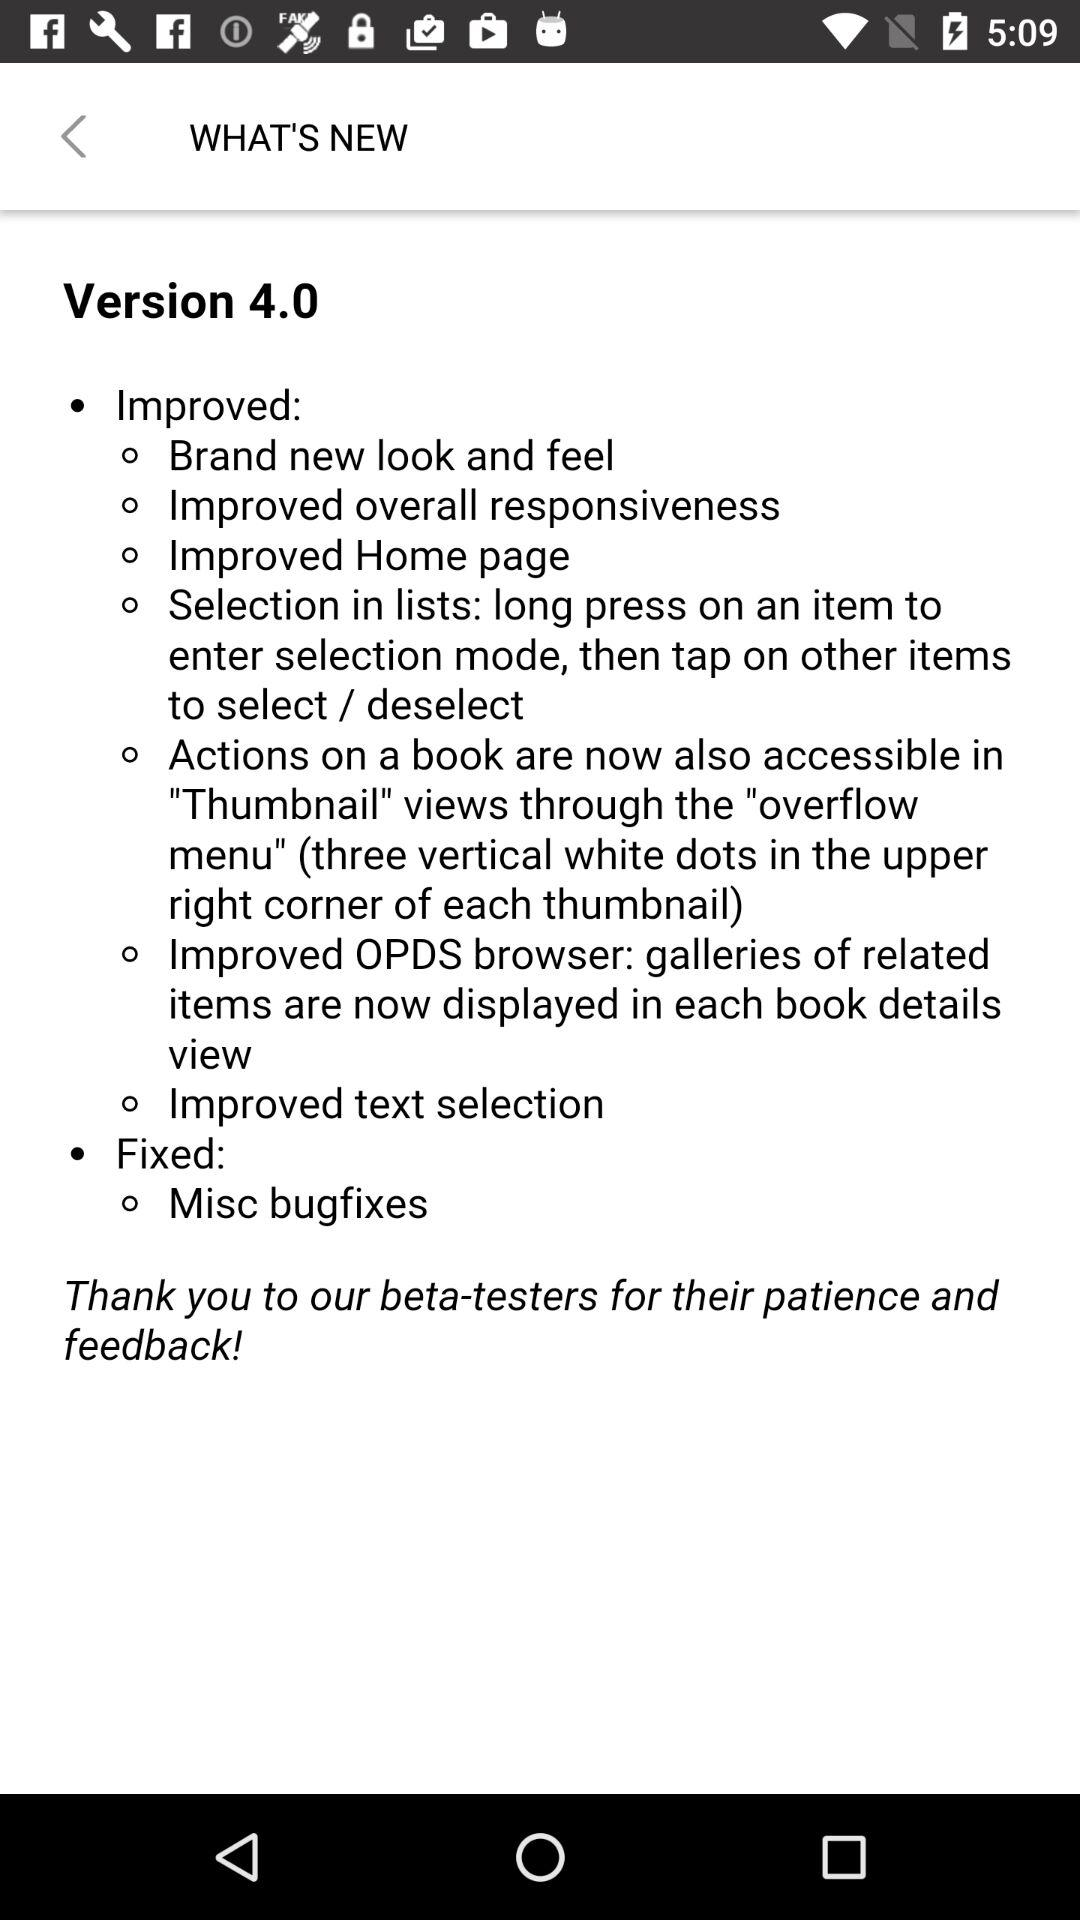What is the version of the application? The version of the application is 4.0. 